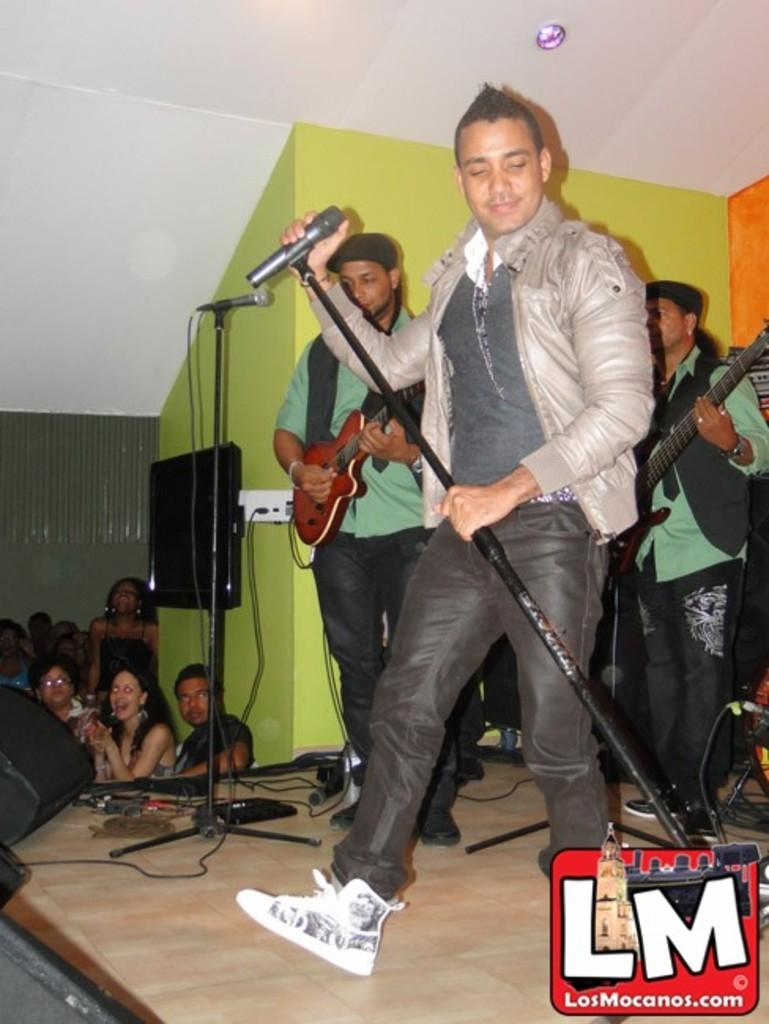What is the person on the stage doing? The person is standing on a stage and holding a microphone. What are the people in the image doing besides the person on the stage? There are people playing guitar in the image. What can be seen in the background of the image? There are people visible in the background, a monitor, and a wall. What type of credit card is the person on the stage using to pay for dinner? The image does not show any credit cards or mention dinner, so it is not possible to answer that question. 